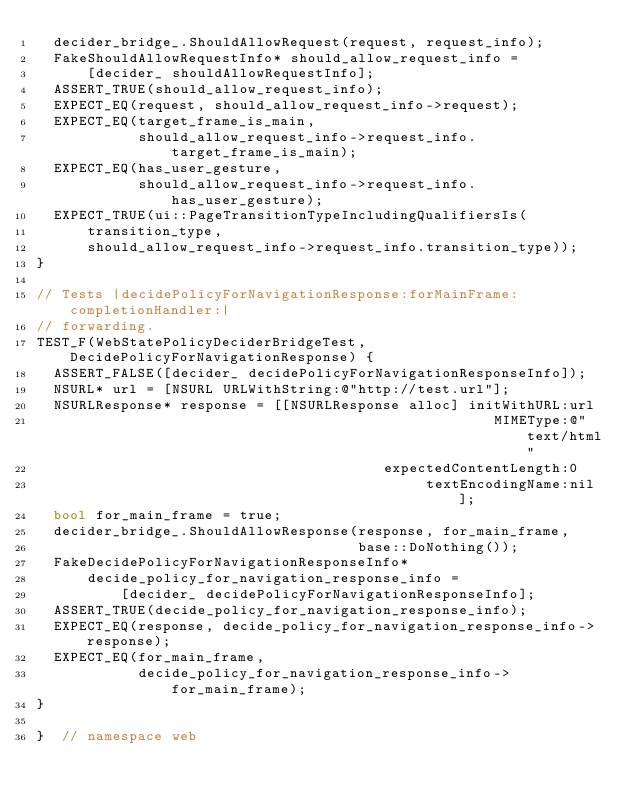<code> <loc_0><loc_0><loc_500><loc_500><_ObjectiveC_>  decider_bridge_.ShouldAllowRequest(request, request_info);
  FakeShouldAllowRequestInfo* should_allow_request_info =
      [decider_ shouldAllowRequestInfo];
  ASSERT_TRUE(should_allow_request_info);
  EXPECT_EQ(request, should_allow_request_info->request);
  EXPECT_EQ(target_frame_is_main,
            should_allow_request_info->request_info.target_frame_is_main);
  EXPECT_EQ(has_user_gesture,
            should_allow_request_info->request_info.has_user_gesture);
  EXPECT_TRUE(ui::PageTransitionTypeIncludingQualifiersIs(
      transition_type,
      should_allow_request_info->request_info.transition_type));
}

// Tests |decidePolicyForNavigationResponse:forMainFrame:completionHandler:|
// forwarding.
TEST_F(WebStatePolicyDeciderBridgeTest, DecidePolicyForNavigationResponse) {
  ASSERT_FALSE([decider_ decidePolicyForNavigationResponseInfo]);
  NSURL* url = [NSURL URLWithString:@"http://test.url"];
  NSURLResponse* response = [[NSURLResponse alloc] initWithURL:url
                                                      MIMEType:@"text/html"
                                         expectedContentLength:0
                                              textEncodingName:nil];
  bool for_main_frame = true;
  decider_bridge_.ShouldAllowResponse(response, for_main_frame,
                                      base::DoNothing());
  FakeDecidePolicyForNavigationResponseInfo*
      decide_policy_for_navigation_response_info =
          [decider_ decidePolicyForNavigationResponseInfo];
  ASSERT_TRUE(decide_policy_for_navigation_response_info);
  EXPECT_EQ(response, decide_policy_for_navigation_response_info->response);
  EXPECT_EQ(for_main_frame,
            decide_policy_for_navigation_response_info->for_main_frame);
}

}  // namespace web
</code> 